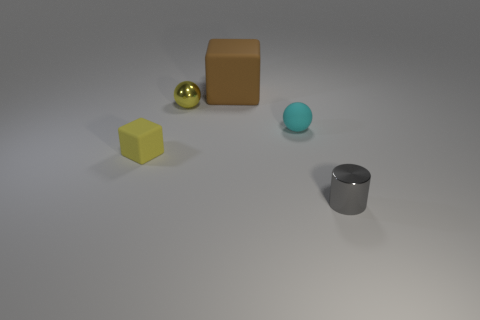How many yellow objects are in front of the cyan rubber thing?
Keep it short and to the point. 1. What is the size of the matte ball?
Give a very brief answer. Small. There is a matte sphere that is the same size as the yellow metallic object; what is its color?
Give a very brief answer. Cyan. Are there any big matte cubes that have the same color as the cylinder?
Your response must be concise. No. What is the material of the brown cube?
Your answer should be compact. Rubber. What number of large gray metallic objects are there?
Provide a succinct answer. 0. There is a matte cube right of the yellow metallic sphere; is it the same color as the block left of the small yellow sphere?
Offer a terse response. No. There is a sphere that is the same color as the tiny block; what is its size?
Keep it short and to the point. Small. What number of other objects are there of the same size as the cyan thing?
Make the answer very short. 3. There is a tiny metallic object in front of the tiny yellow shiny sphere; what color is it?
Provide a short and direct response. Gray. 